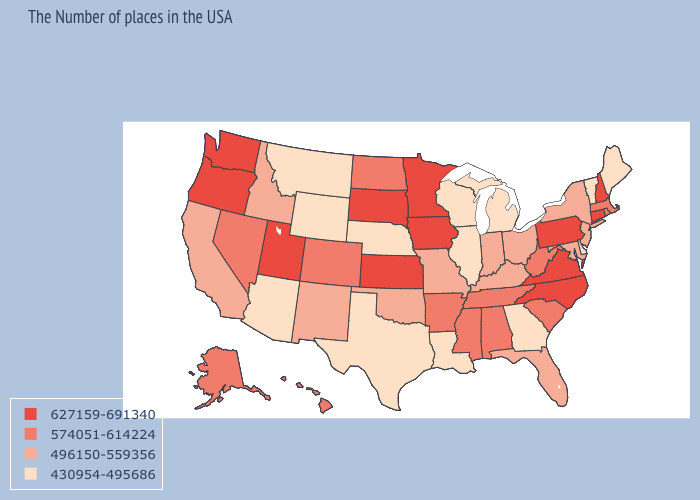What is the lowest value in states that border New Jersey?
Short answer required. 430954-495686. What is the value of Hawaii?
Give a very brief answer. 574051-614224. What is the value of Wisconsin?
Quick response, please. 430954-495686. What is the value of Iowa?
Quick response, please. 627159-691340. Among the states that border Alabama , which have the lowest value?
Keep it brief. Georgia. Name the states that have a value in the range 627159-691340?
Short answer required. New Hampshire, Connecticut, Pennsylvania, Virginia, North Carolina, Minnesota, Iowa, Kansas, South Dakota, Utah, Washington, Oregon. Does Arkansas have the lowest value in the South?
Write a very short answer. No. What is the value of Tennessee?
Answer briefly. 574051-614224. What is the lowest value in the USA?
Quick response, please. 430954-495686. What is the value of Arkansas?
Quick response, please. 574051-614224. What is the highest value in the USA?
Answer briefly. 627159-691340. What is the lowest value in the USA?
Write a very short answer. 430954-495686. Is the legend a continuous bar?
Answer briefly. No. What is the value of Rhode Island?
Concise answer only. 574051-614224. Does the first symbol in the legend represent the smallest category?
Answer briefly. No. 